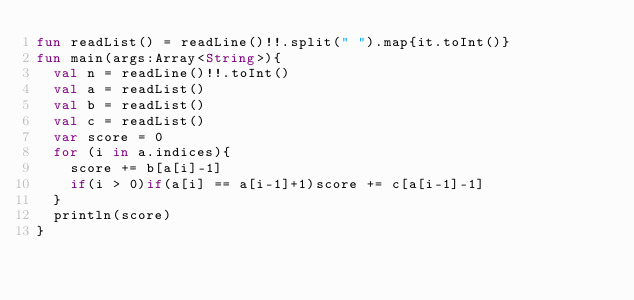<code> <loc_0><loc_0><loc_500><loc_500><_Kotlin_>fun readList() = readLine()!!.split(" ").map{it.toInt()}
fun main(args:Array<String>){
  val n = readLine()!!.toInt()
  val a = readList()
  val b = readList()
  val c = readList()
  var score = 0
  for (i in a.indices){
    score += b[a[i]-1]
    if(i > 0)if(a[i] == a[i-1]+1)score += c[a[i-1]-1]
  }
  println(score)
}</code> 